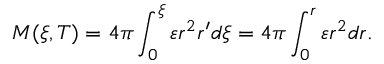<formula> <loc_0><loc_0><loc_500><loc_500>M ( \xi , T ) = 4 \pi \int _ { 0 } ^ { \xi } \varepsilon r ^ { 2 } r ^ { \prime } d \xi = 4 \pi \int _ { 0 } ^ { r } \varepsilon r ^ { 2 } d r .</formula> 